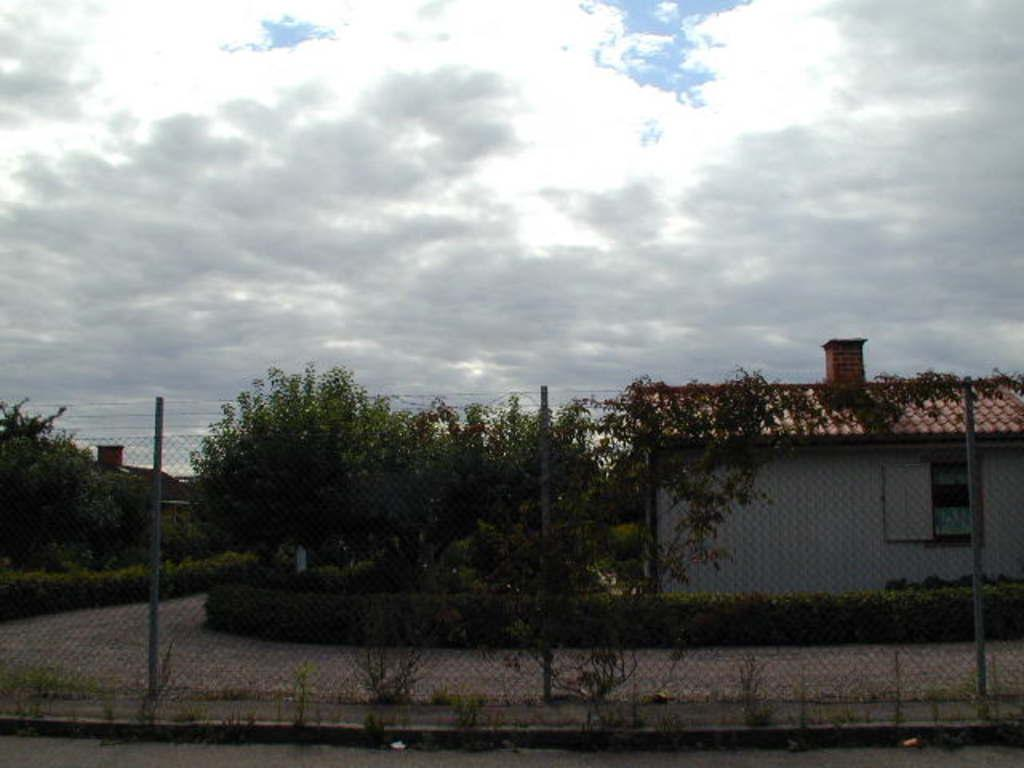What can be seen in the foreground of the picture? There are plants and fencing in the foreground of the picture. What is located in the center of the picture? There are trees, a road, and houses in the center of the picture. What is visible at the top of the picture? The sky is visible at the top of the picture. What is the condition of the sky in the picture? The sky is cloudy in the picture. How many boats are visible in the picture? There are no boats present in the picture. What is the size of the largest house in the picture? The provided facts do not include information about the size of the houses, so it cannot be determined from the image. 